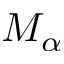Convert formula to latex. <formula><loc_0><loc_0><loc_500><loc_500>M _ { \alpha }</formula> 